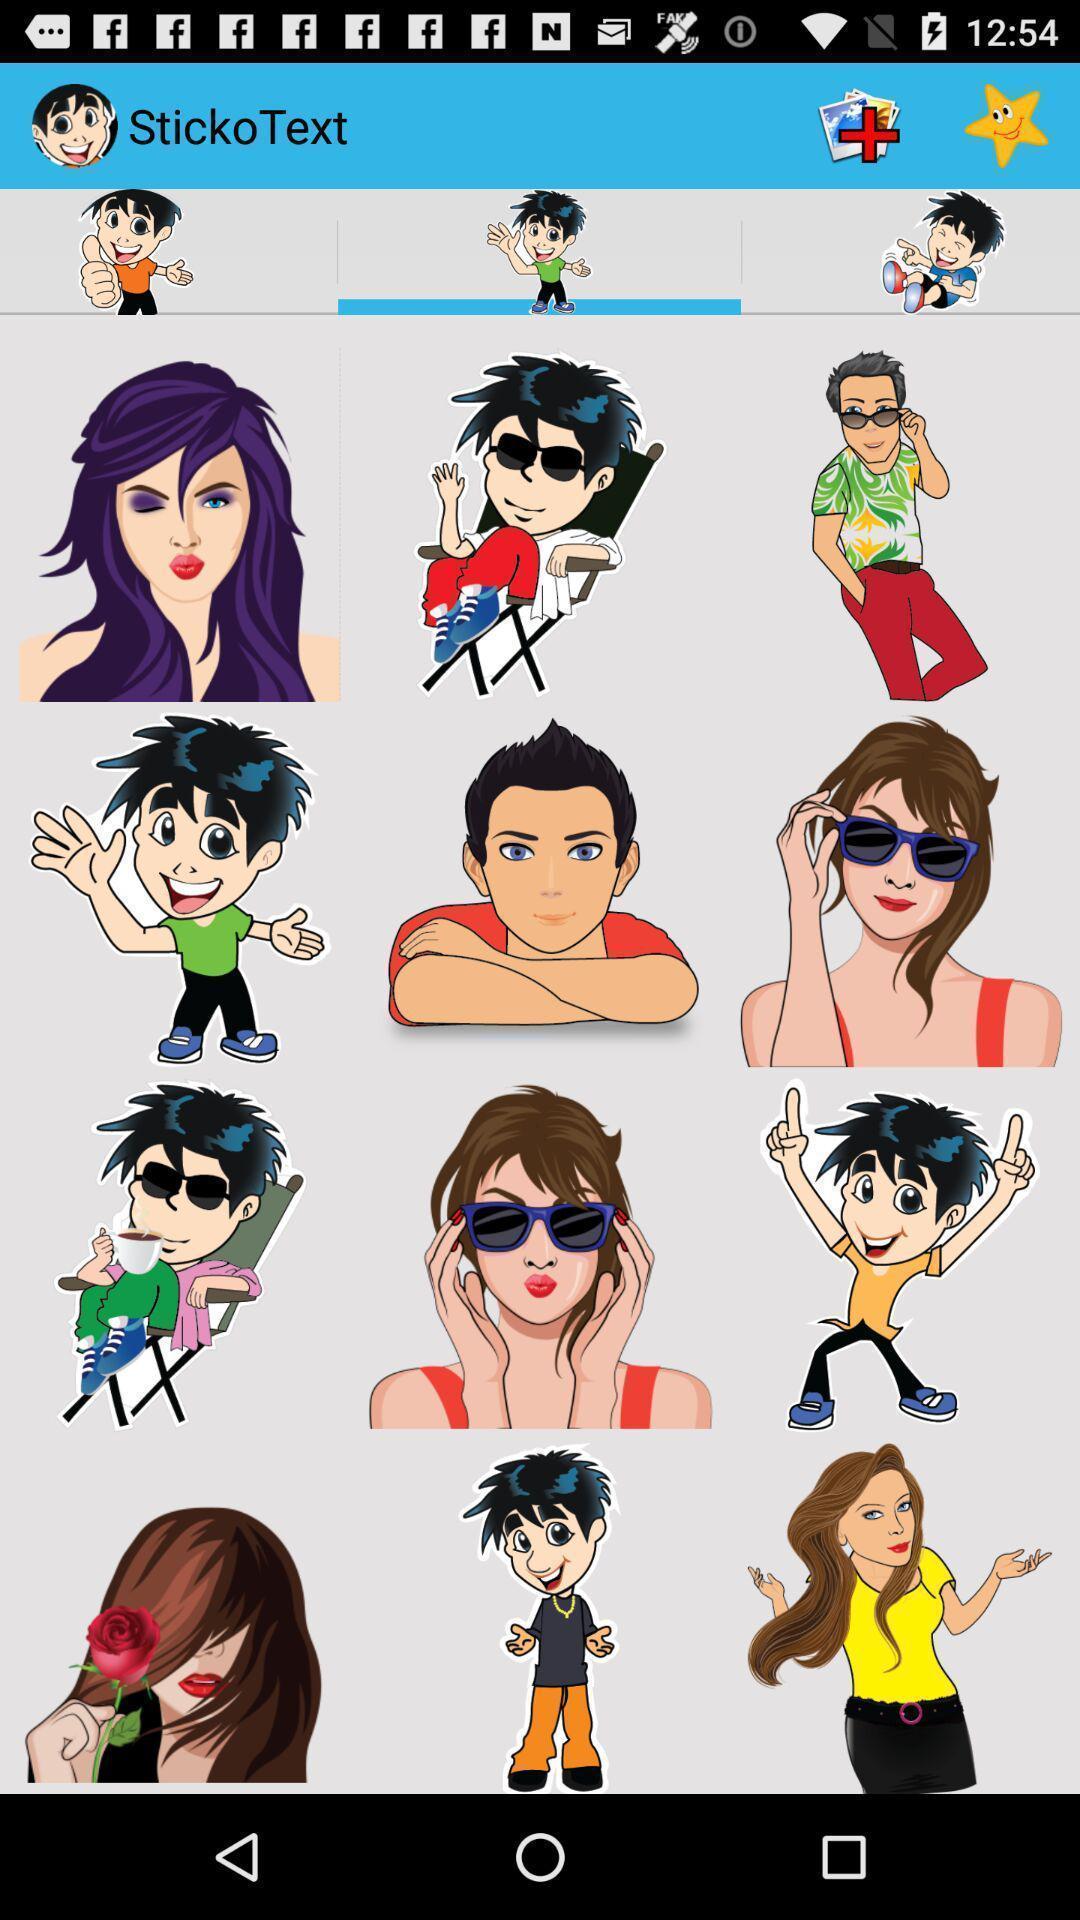What details can you identify in this image? Page screen displaying several stickers in messaging app. 